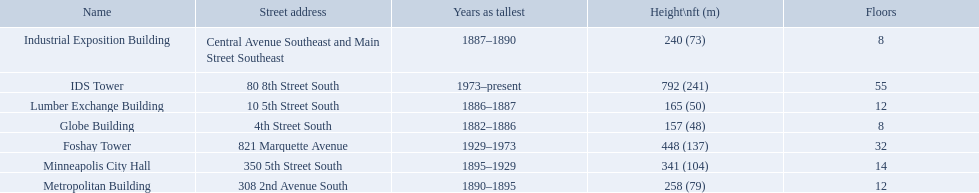What years was 240 ft considered tall? 1887–1890. What building held this record? Industrial Exposition Building. What are all the building names? Globe Building, Lumber Exchange Building, Industrial Exposition Building, Metropolitan Building, Minneapolis City Hall, Foshay Tower, IDS Tower. And their heights? 157 (48), 165 (50), 240 (73), 258 (79), 341 (104), 448 (137), 792 (241). Between metropolitan building and lumber exchange building, which is taller? Metropolitan Building. What are the tallest buildings in minneapolis? Globe Building, Lumber Exchange Building, Industrial Exposition Building, Metropolitan Building, Minneapolis City Hall, Foshay Tower, IDS Tower. What is the height of the metropolitan building? 258 (79). What is the height of the lumber exchange building? 165 (50). Of those two which is taller? Metropolitan Building. What are the heights of the buildings? 157 (48), 165 (50), 240 (73), 258 (79), 341 (104), 448 (137), 792 (241). What building is 240 ft tall? Industrial Exposition Building. 